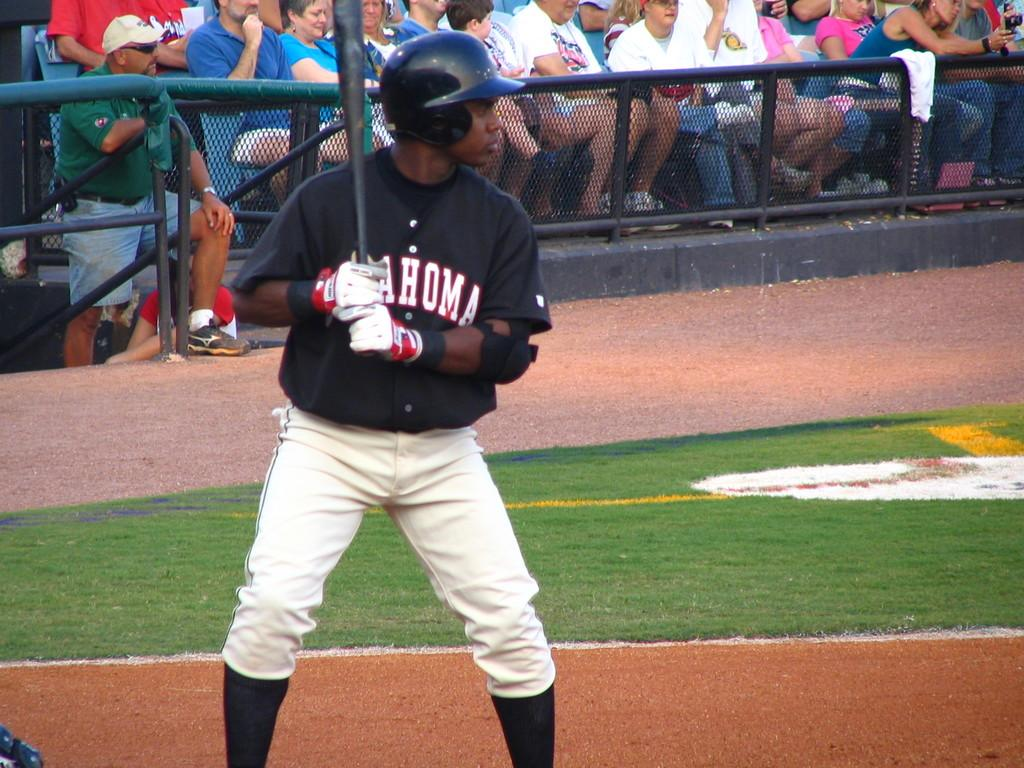<image>
Give a short and clear explanation of the subsequent image. A baseball player with a jersey that says Oklahoma is up to bat. 